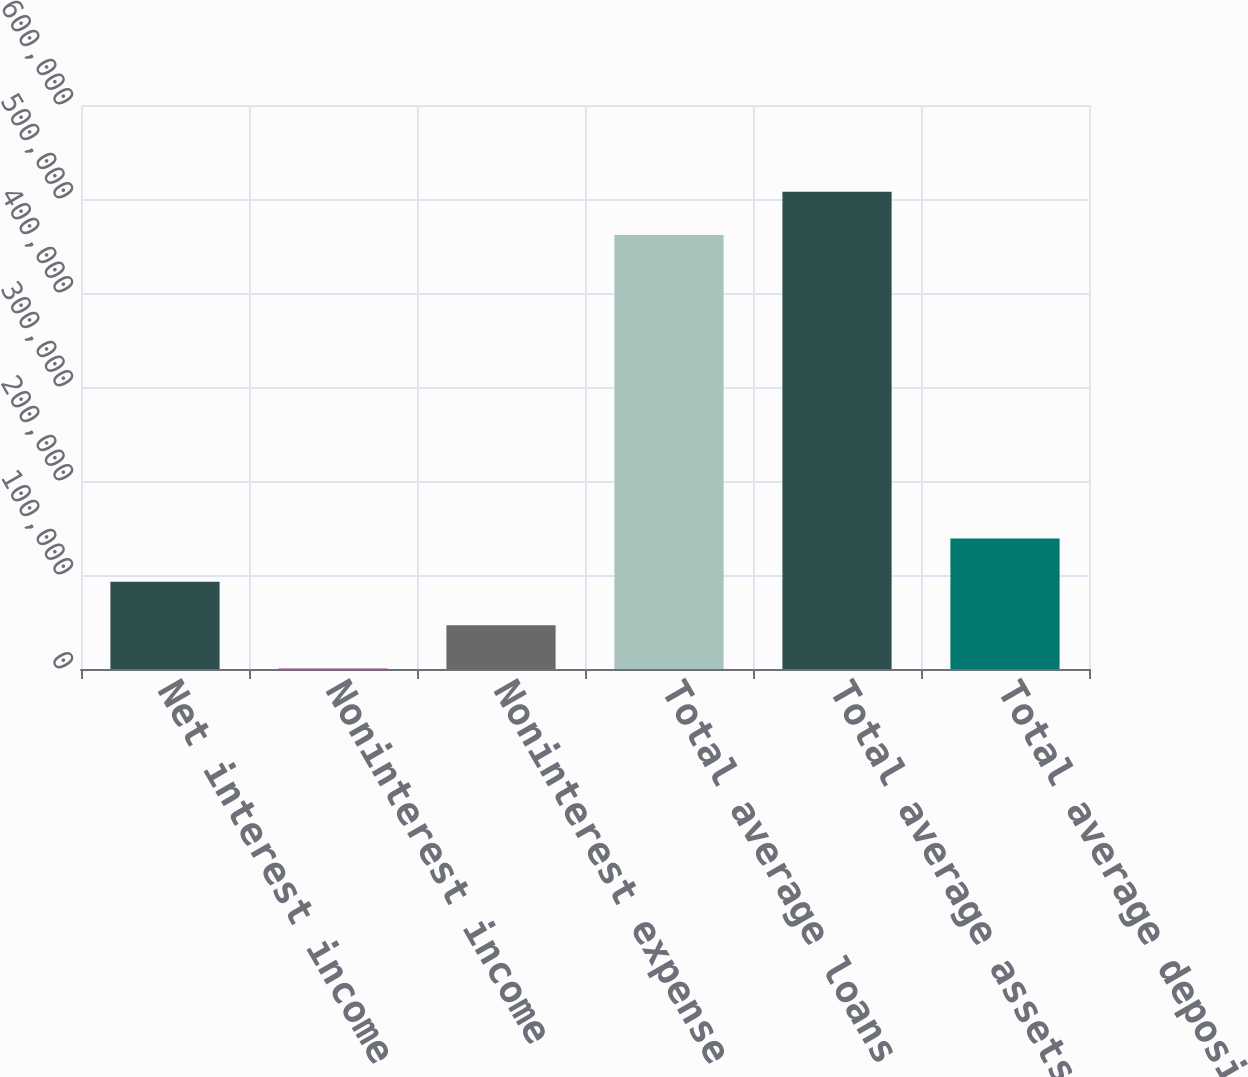Convert chart. <chart><loc_0><loc_0><loc_500><loc_500><bar_chart><fcel>Net interest income<fcel>Noninterest income<fcel>Noninterest expense<fcel>Total average loans net of<fcel>Total average assets<fcel>Total average deposits<nl><fcel>92736.2<fcel>496<fcel>46616.1<fcel>461620<fcel>507740<fcel>138856<nl></chart> 